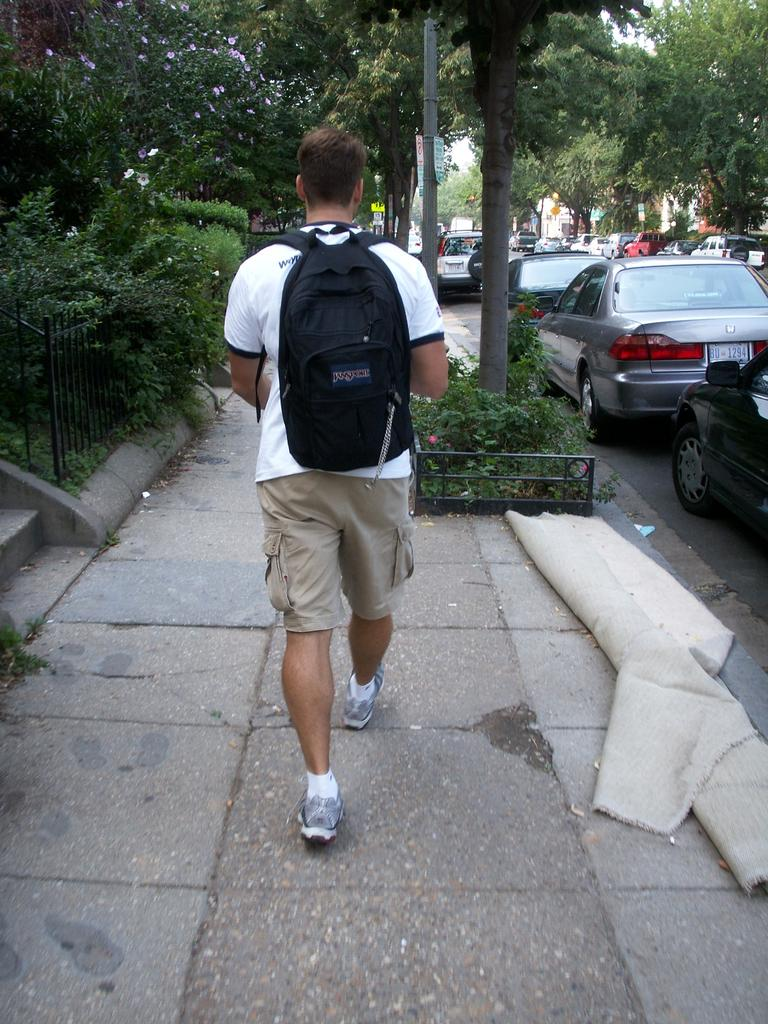What is the person in the image doing? The person in the image is walking. What is the person carrying while walking? The person is carrying a bag. What can be seen in the background of the image? There are trees, a pole, and parked cars in the background of the image. What type of cabbage is hanging from the wire in the image? There is no cabbage or wire present in the image. What color is the person's shirt in the image? The provided facts do not mention the color of the person's shirt, so it cannot be determined from the image. 